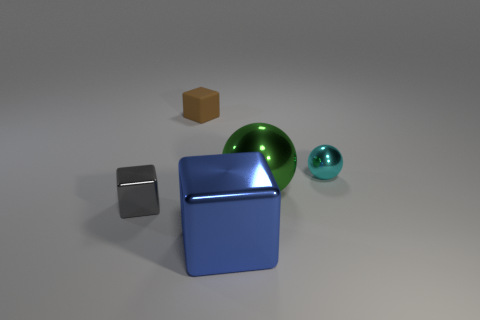What number of blocks are either blue things or gray objects?
Provide a succinct answer. 2. There is a blue metal thing that is to the right of the gray metallic thing; is there a brown rubber cube that is behind it?
Make the answer very short. Yes. Is the number of large green shiny cylinders less than the number of metallic blocks?
Provide a short and direct response. Yes. How many tiny objects are the same shape as the big blue object?
Make the answer very short. 2. How many brown objects are either tiny rubber cubes or tiny balls?
Give a very brief answer. 1. How big is the metal cube that is behind the large metal block that is in front of the tiny rubber cube?
Your answer should be compact. Small. There is a gray thing that is the same shape as the blue metal object; what is its material?
Give a very brief answer. Metal. How many yellow cylinders are the same size as the gray metallic thing?
Your response must be concise. 0. Does the cyan shiny ball have the same size as the rubber cube?
Give a very brief answer. Yes. What is the size of the object that is in front of the small cyan ball and to the right of the blue metal thing?
Keep it short and to the point. Large. 